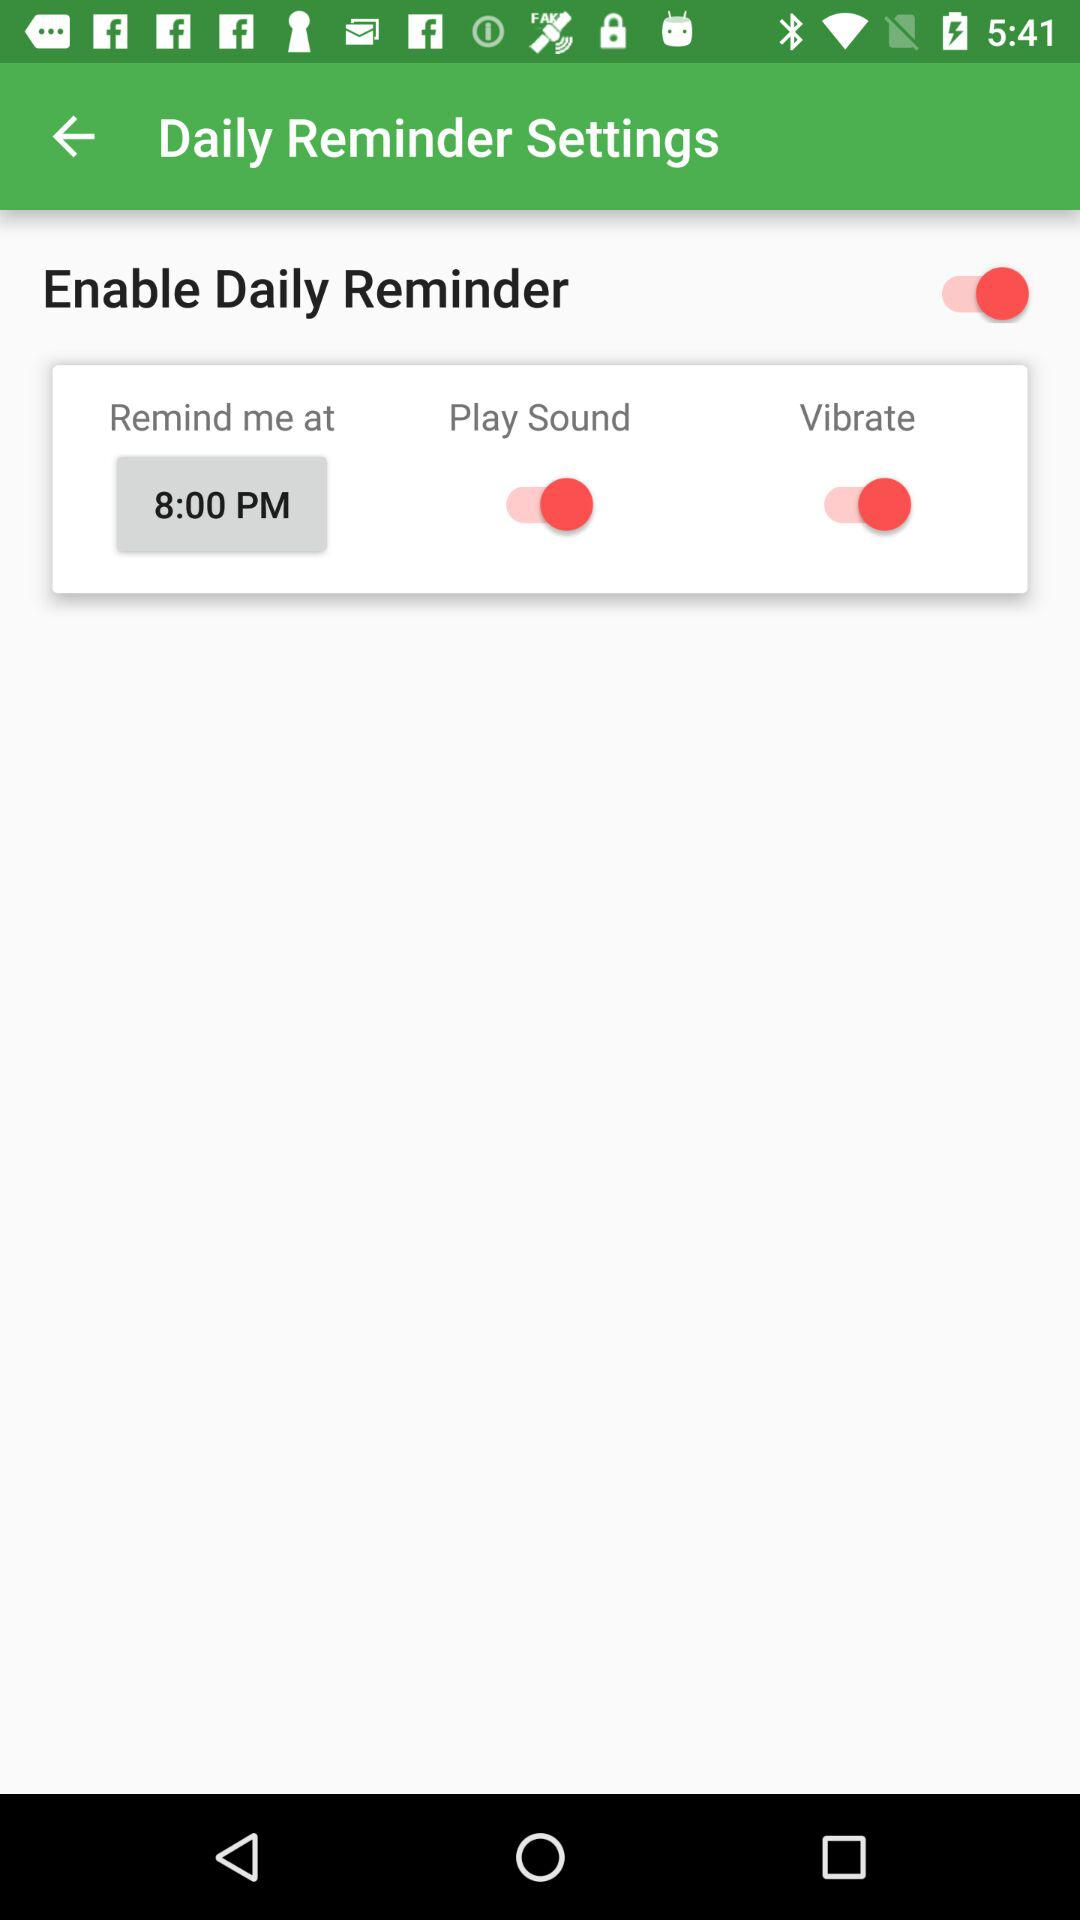What is the status of the "Enable Daily Reminder"? The status is on. 